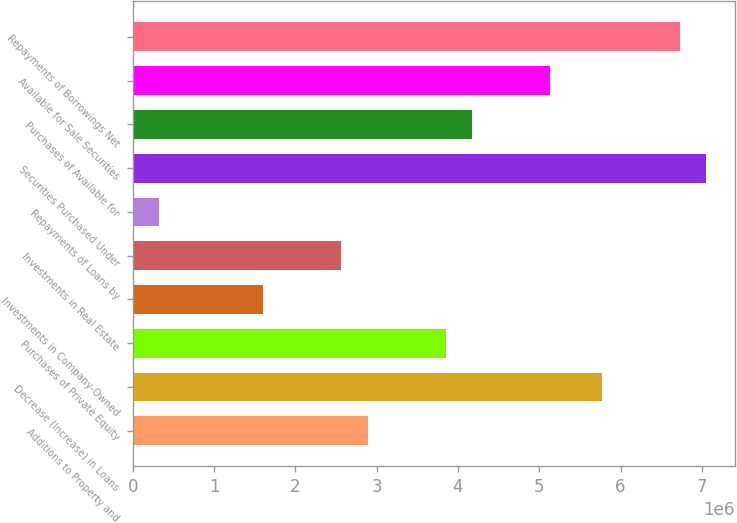Convert chart. <chart><loc_0><loc_0><loc_500><loc_500><bar_chart><fcel>Additions to Property and<fcel>Decrease (Increase) in Loans<fcel>Purchases of Private Equity<fcel>Investments in Company-Owned<fcel>Investments in Real Estate<fcel>Repayments of Loans by<fcel>Securities Purchased Under<fcel>Purchases of Available for<fcel>Available for Sale Securities<fcel>Repayments of Borrowings Net<nl><fcel>2.88689e+06<fcel>5.77233e+06<fcel>3.8487e+06<fcel>1.60447e+06<fcel>2.56628e+06<fcel>322054<fcel>7.05474e+06<fcel>4.16931e+06<fcel>5.13112e+06<fcel>6.73414e+06<nl></chart> 